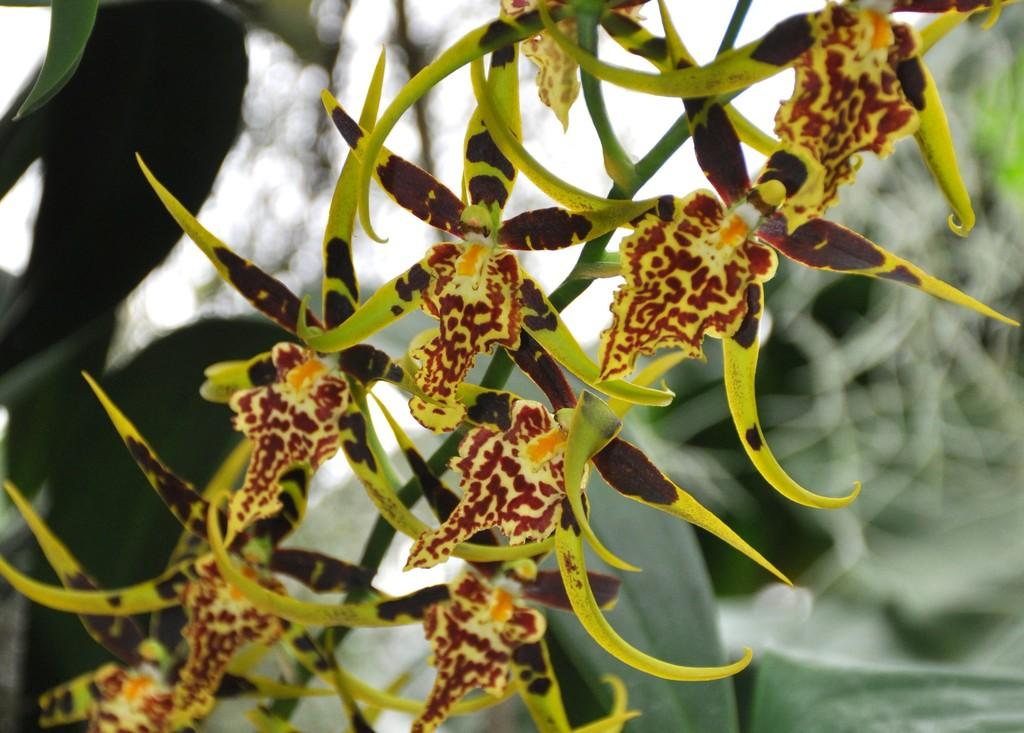What is present in the image? There are flowers in the image. Can you describe the background of the image? The background of the image is blurred. How many tails can be seen on the flowers in the image? There are no tails present on the flowers in the image, as flowers do not have tails. 